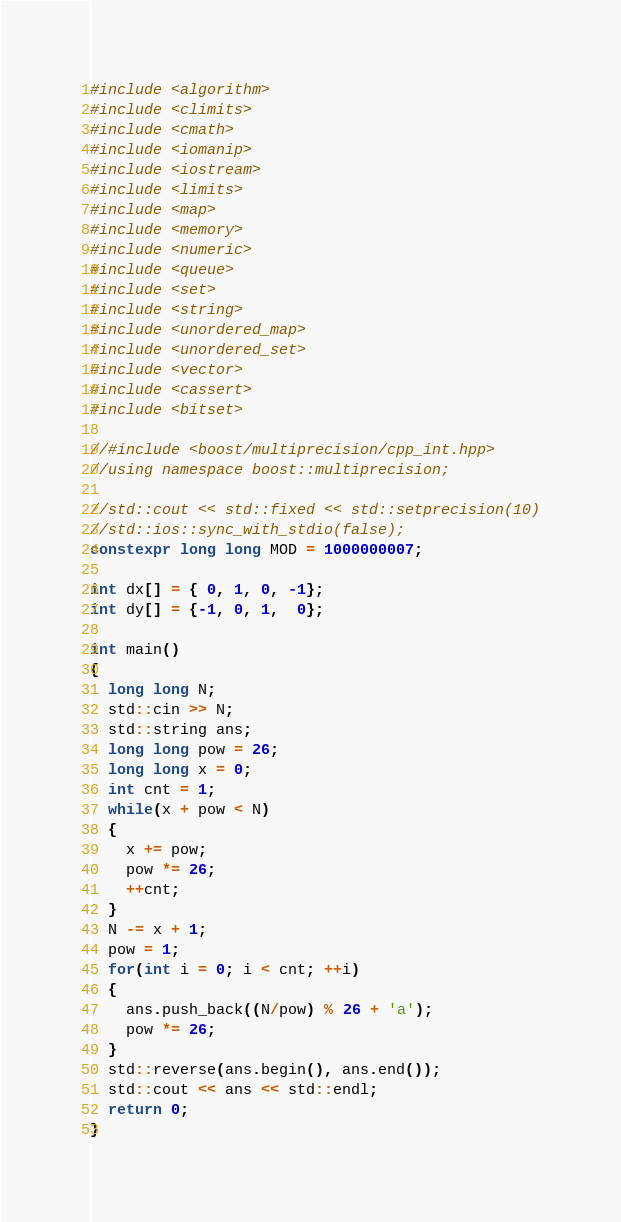<code> <loc_0><loc_0><loc_500><loc_500><_C++_>#include <algorithm>
#include <climits>
#include <cmath>
#include <iomanip>
#include <iostream>
#include <limits>
#include <map>
#include <memory>
#include <numeric>
#include <queue>
#include <set>
#include <string>
#include <unordered_map>
#include <unordered_set>
#include <vector>
#include <cassert>
#include <bitset>

//#include <boost/multiprecision/cpp_int.hpp>
//using namespace boost::multiprecision;

//std::cout << std::fixed << std::setprecision(10)
//std::ios::sync_with_stdio(false);
constexpr long long MOD = 1000000007;

int dx[] = { 0, 1, 0, -1};
int dy[] = {-1, 0, 1,  0};

int main()
{
  long long N;
  std::cin >> N;
  std::string ans;
  long long pow = 26;
  long long x = 0;
  int cnt = 1;
  while(x + pow < N)
  {
    x += pow;
    pow *= 26;
    ++cnt;
  }
  N -= x + 1;
  pow = 1;
  for(int i = 0; i < cnt; ++i)
  {
    ans.push_back((N/pow) % 26 + 'a');
    pow *= 26;
  }
  std::reverse(ans.begin(), ans.end());
  std::cout << ans << std::endl;
  return 0;
}

</code> 